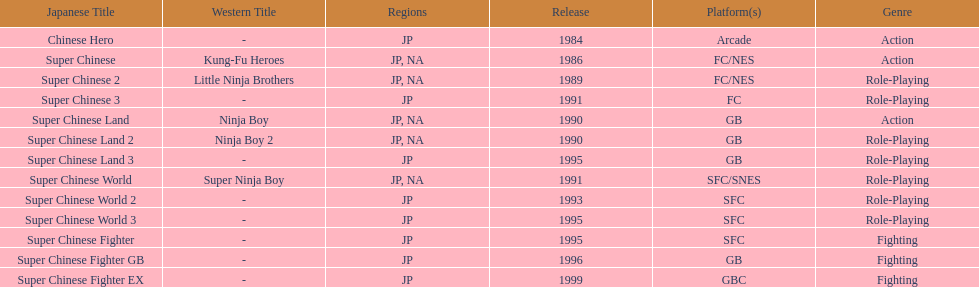When was the final super chinese game made available? 1999. 